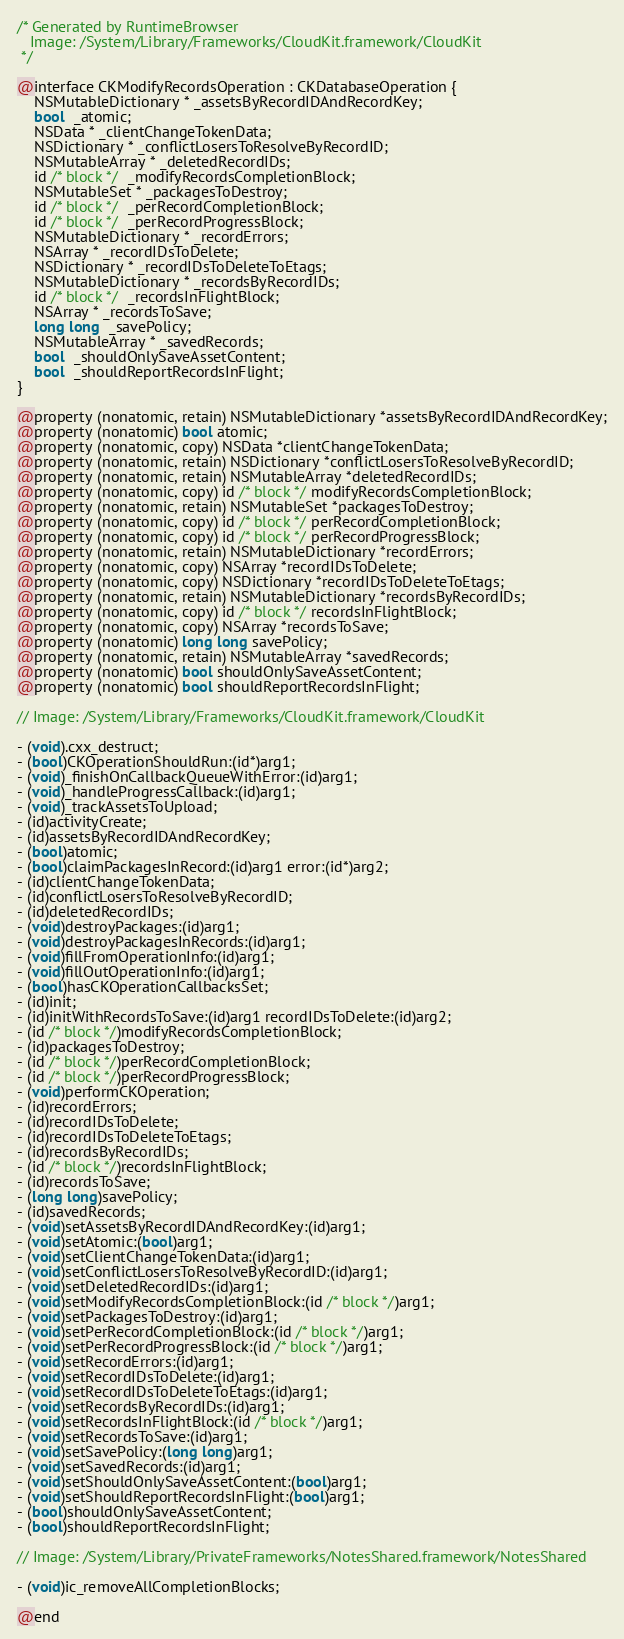<code> <loc_0><loc_0><loc_500><loc_500><_C_>/* Generated by RuntimeBrowser
   Image: /System/Library/Frameworks/CloudKit.framework/CloudKit
 */

@interface CKModifyRecordsOperation : CKDatabaseOperation {
    NSMutableDictionary * _assetsByRecordIDAndRecordKey;
    bool  _atomic;
    NSData * _clientChangeTokenData;
    NSDictionary * _conflictLosersToResolveByRecordID;
    NSMutableArray * _deletedRecordIDs;
    id /* block */  _modifyRecordsCompletionBlock;
    NSMutableSet * _packagesToDestroy;
    id /* block */  _perRecordCompletionBlock;
    id /* block */  _perRecordProgressBlock;
    NSMutableDictionary * _recordErrors;
    NSArray * _recordIDsToDelete;
    NSDictionary * _recordIDsToDeleteToEtags;
    NSMutableDictionary * _recordsByRecordIDs;
    id /* block */  _recordsInFlightBlock;
    NSArray * _recordsToSave;
    long long  _savePolicy;
    NSMutableArray * _savedRecords;
    bool  _shouldOnlySaveAssetContent;
    bool  _shouldReportRecordsInFlight;
}

@property (nonatomic, retain) NSMutableDictionary *assetsByRecordIDAndRecordKey;
@property (nonatomic) bool atomic;
@property (nonatomic, copy) NSData *clientChangeTokenData;
@property (nonatomic, retain) NSDictionary *conflictLosersToResolveByRecordID;
@property (nonatomic, retain) NSMutableArray *deletedRecordIDs;
@property (nonatomic, copy) id /* block */ modifyRecordsCompletionBlock;
@property (nonatomic, retain) NSMutableSet *packagesToDestroy;
@property (nonatomic, copy) id /* block */ perRecordCompletionBlock;
@property (nonatomic, copy) id /* block */ perRecordProgressBlock;
@property (nonatomic, retain) NSMutableDictionary *recordErrors;
@property (nonatomic, copy) NSArray *recordIDsToDelete;
@property (nonatomic, copy) NSDictionary *recordIDsToDeleteToEtags;
@property (nonatomic, retain) NSMutableDictionary *recordsByRecordIDs;
@property (nonatomic, copy) id /* block */ recordsInFlightBlock;
@property (nonatomic, copy) NSArray *recordsToSave;
@property (nonatomic) long long savePolicy;
@property (nonatomic, retain) NSMutableArray *savedRecords;
@property (nonatomic) bool shouldOnlySaveAssetContent;
@property (nonatomic) bool shouldReportRecordsInFlight;

// Image: /System/Library/Frameworks/CloudKit.framework/CloudKit

- (void).cxx_destruct;
- (bool)CKOperationShouldRun:(id*)arg1;
- (void)_finishOnCallbackQueueWithError:(id)arg1;
- (void)_handleProgressCallback:(id)arg1;
- (void)_trackAssetsToUpload;
- (id)activityCreate;
- (id)assetsByRecordIDAndRecordKey;
- (bool)atomic;
- (bool)claimPackagesInRecord:(id)arg1 error:(id*)arg2;
- (id)clientChangeTokenData;
- (id)conflictLosersToResolveByRecordID;
- (id)deletedRecordIDs;
- (void)destroyPackages:(id)arg1;
- (void)destroyPackagesInRecords:(id)arg1;
- (void)fillFromOperationInfo:(id)arg1;
- (void)fillOutOperationInfo:(id)arg1;
- (bool)hasCKOperationCallbacksSet;
- (id)init;
- (id)initWithRecordsToSave:(id)arg1 recordIDsToDelete:(id)arg2;
- (id /* block */)modifyRecordsCompletionBlock;
- (id)packagesToDestroy;
- (id /* block */)perRecordCompletionBlock;
- (id /* block */)perRecordProgressBlock;
- (void)performCKOperation;
- (id)recordErrors;
- (id)recordIDsToDelete;
- (id)recordIDsToDeleteToEtags;
- (id)recordsByRecordIDs;
- (id /* block */)recordsInFlightBlock;
- (id)recordsToSave;
- (long long)savePolicy;
- (id)savedRecords;
- (void)setAssetsByRecordIDAndRecordKey:(id)arg1;
- (void)setAtomic:(bool)arg1;
- (void)setClientChangeTokenData:(id)arg1;
- (void)setConflictLosersToResolveByRecordID:(id)arg1;
- (void)setDeletedRecordIDs:(id)arg1;
- (void)setModifyRecordsCompletionBlock:(id /* block */)arg1;
- (void)setPackagesToDestroy:(id)arg1;
- (void)setPerRecordCompletionBlock:(id /* block */)arg1;
- (void)setPerRecordProgressBlock:(id /* block */)arg1;
- (void)setRecordErrors:(id)arg1;
- (void)setRecordIDsToDelete:(id)arg1;
- (void)setRecordIDsToDeleteToEtags:(id)arg1;
- (void)setRecordsByRecordIDs:(id)arg1;
- (void)setRecordsInFlightBlock:(id /* block */)arg1;
- (void)setRecordsToSave:(id)arg1;
- (void)setSavePolicy:(long long)arg1;
- (void)setSavedRecords:(id)arg1;
- (void)setShouldOnlySaveAssetContent:(bool)arg1;
- (void)setShouldReportRecordsInFlight:(bool)arg1;
- (bool)shouldOnlySaveAssetContent;
- (bool)shouldReportRecordsInFlight;

// Image: /System/Library/PrivateFrameworks/NotesShared.framework/NotesShared

- (void)ic_removeAllCompletionBlocks;

@end
</code> 